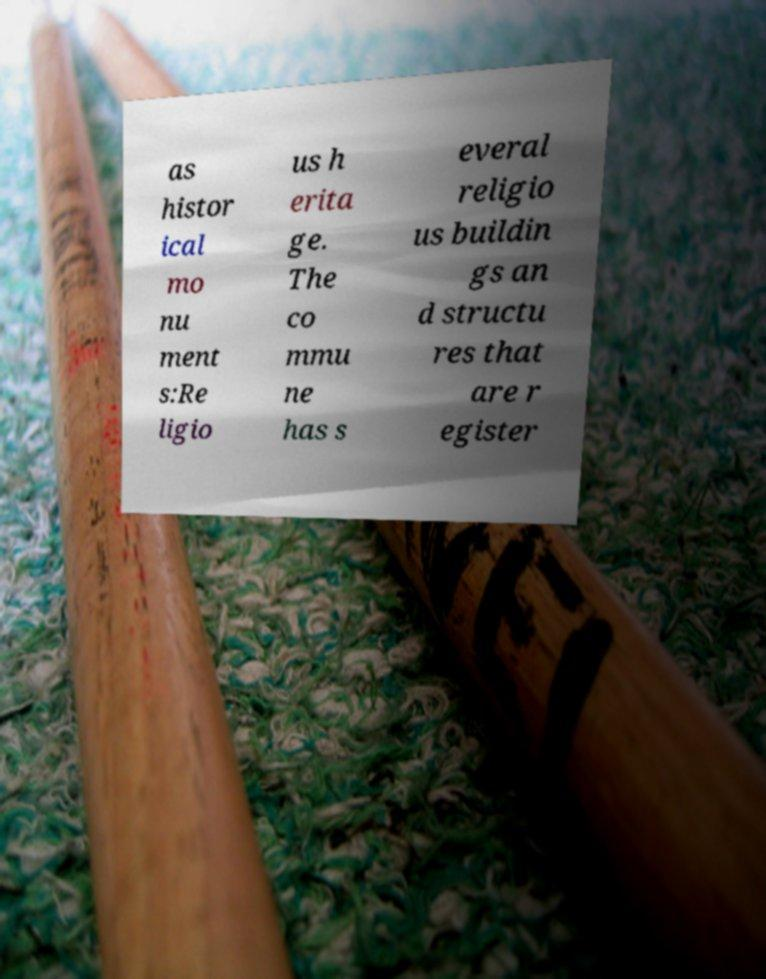There's text embedded in this image that I need extracted. Can you transcribe it verbatim? as histor ical mo nu ment s:Re ligio us h erita ge. The co mmu ne has s everal religio us buildin gs an d structu res that are r egister 